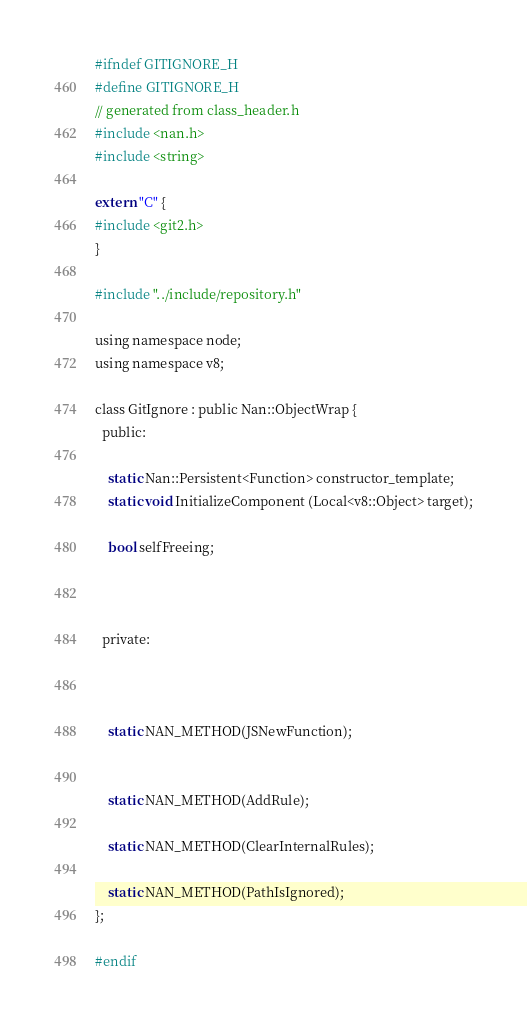Convert code to text. <code><loc_0><loc_0><loc_500><loc_500><_C_>#ifndef GITIGNORE_H
#define GITIGNORE_H
// generated from class_header.h
#include <nan.h>
#include <string>

extern "C" {
#include <git2.h>
}

#include "../include/repository.h"

using namespace node;
using namespace v8;

class GitIgnore : public Nan::ObjectWrap {
  public:

    static Nan::Persistent<Function> constructor_template;
    static void InitializeComponent (Local<v8::Object> target);

    bool selfFreeing;

             

  private:


             
    static NAN_METHOD(JSNewFunction);


    static NAN_METHOD(AddRule);

    static NAN_METHOD(ClearInternalRules);

    static NAN_METHOD(PathIsIgnored);
};

#endif
</code> 